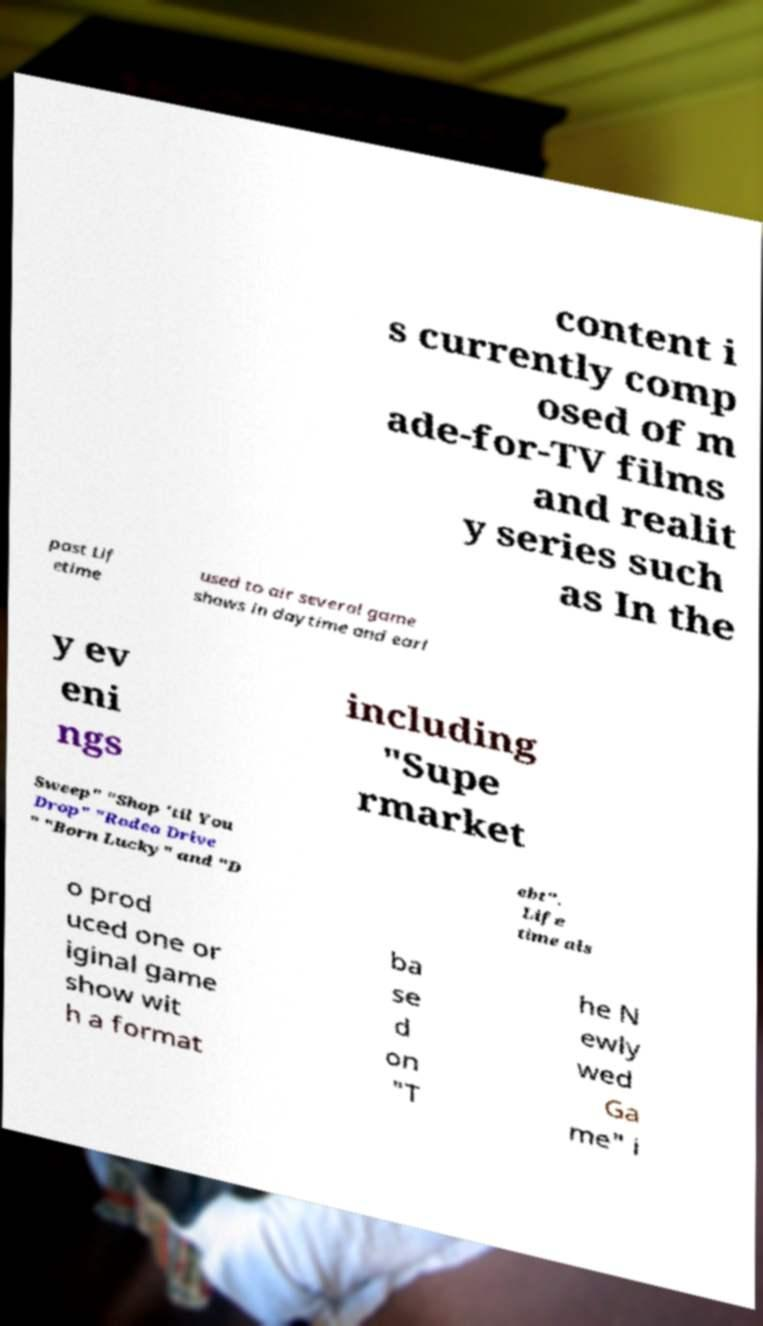Could you extract and type out the text from this image? content i s currently comp osed of m ade-for-TV films and realit y series such as In the past Lif etime used to air several game shows in daytime and earl y ev eni ngs including "Supe rmarket Sweep" "Shop 'til You Drop" "Rodeo Drive " "Born Lucky" and "D ebt". Life time als o prod uced one or iginal game show wit h a format ba se d on "T he N ewly wed Ga me" i 